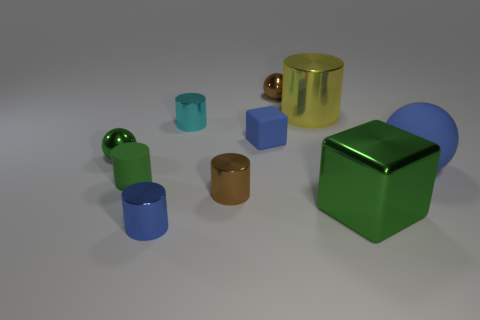What material is the cylinder that is the same color as the matte ball?
Ensure brevity in your answer.  Metal. How many cubes are the same color as the big matte object?
Give a very brief answer. 1. How many big green blocks are the same material as the tiny cyan cylinder?
Ensure brevity in your answer.  1. Do the matte ball and the cube that is left of the tiny brown sphere have the same color?
Offer a terse response. Yes. There is a sphere that is in front of the tiny metal sphere in front of the yellow cylinder; what is its color?
Offer a terse response. Blue. What is the color of the cube that is the same size as the brown sphere?
Your answer should be very brief. Blue. Are there any brown objects of the same shape as the large blue thing?
Your answer should be compact. Yes. What is the shape of the big green shiny object?
Provide a succinct answer. Cube. Are there more small green things behind the tiny brown metal cylinder than matte balls that are on the left side of the big blue rubber sphere?
Make the answer very short. Yes. What number of other objects are the same size as the green metal ball?
Your response must be concise. 6. 